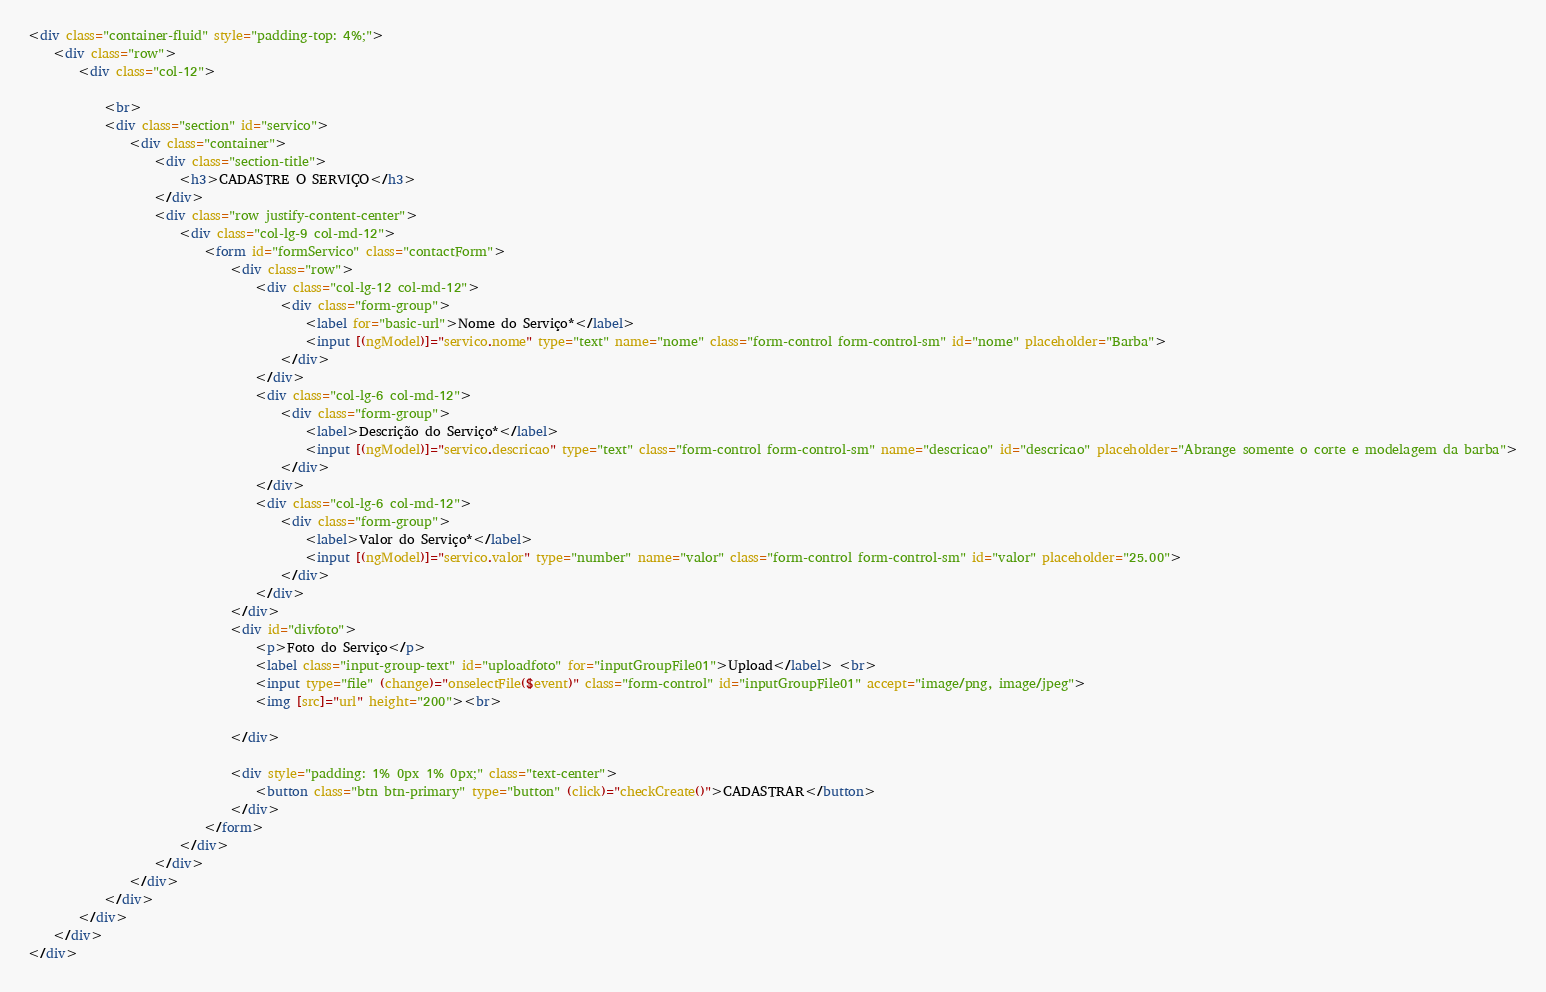<code> <loc_0><loc_0><loc_500><loc_500><_HTML_><div class="container-fluid" style="padding-top: 4%;">
    <div class="row">
        <div class="col-12">

            <br>
            <div class="section" id="servico">
                <div class="container">
                    <div class="section-title">
                        <h3>CADASTRE O SERVIÇO</h3>
                    </div>
                    <div class="row justify-content-center">
                        <div class="col-lg-9 col-md-12">
                            <form id="formServico" class="contactForm">
                                <div class="row">
                                    <div class="col-lg-12 col-md-12">
                                        <div class="form-group">
                                            <label for="basic-url">Nome do Serviço*</label>
                                            <input [(ngModel)]="servico.nome" type="text" name="nome" class="form-control form-control-sm" id="nome" placeholder="Barba">
                                        </div>
                                    </div>
                                    <div class="col-lg-6 col-md-12">
                                        <div class="form-group">
                                            <label>Descrição do Serviço*</label>
                                            <input [(ngModel)]="servico.descricao" type="text" class="form-control form-control-sm" name="descricao" id="descricao" placeholder="Abrange somente o corte e modelagem da barba">
                                        </div>
                                    </div>
                                    <div class="col-lg-6 col-md-12">
                                        <div class="form-group">
                                            <label>Valor do Serviço*</label>
                                            <input [(ngModel)]="servico.valor" type="number" name="valor" class="form-control form-control-sm" id="valor" placeholder="25.00">
                                        </div>
                                    </div>
                                </div>
                                <div id="divfoto">
                                    <p>Foto do Serviço</p>
                                    <label class="input-group-text" id="uploadfoto" for="inputGroupFile01">Upload</label> <br>
                                    <input type="file" (change)="onselectFile($event)" class="form-control" id="inputGroupFile01" accept="image/png, image/jpeg">
                                    <img [src]="url" height="200"><br>

                                </div>

                                <div style="padding: 1% 0px 1% 0px;" class="text-center">
                                    <button class="btn btn-primary" type="button" (click)="checkCreate()">CADASTRAR</button>
                                </div>
                            </form>
                        </div>
                    </div>
                </div>
            </div>
        </div>
    </div>
</div></code> 